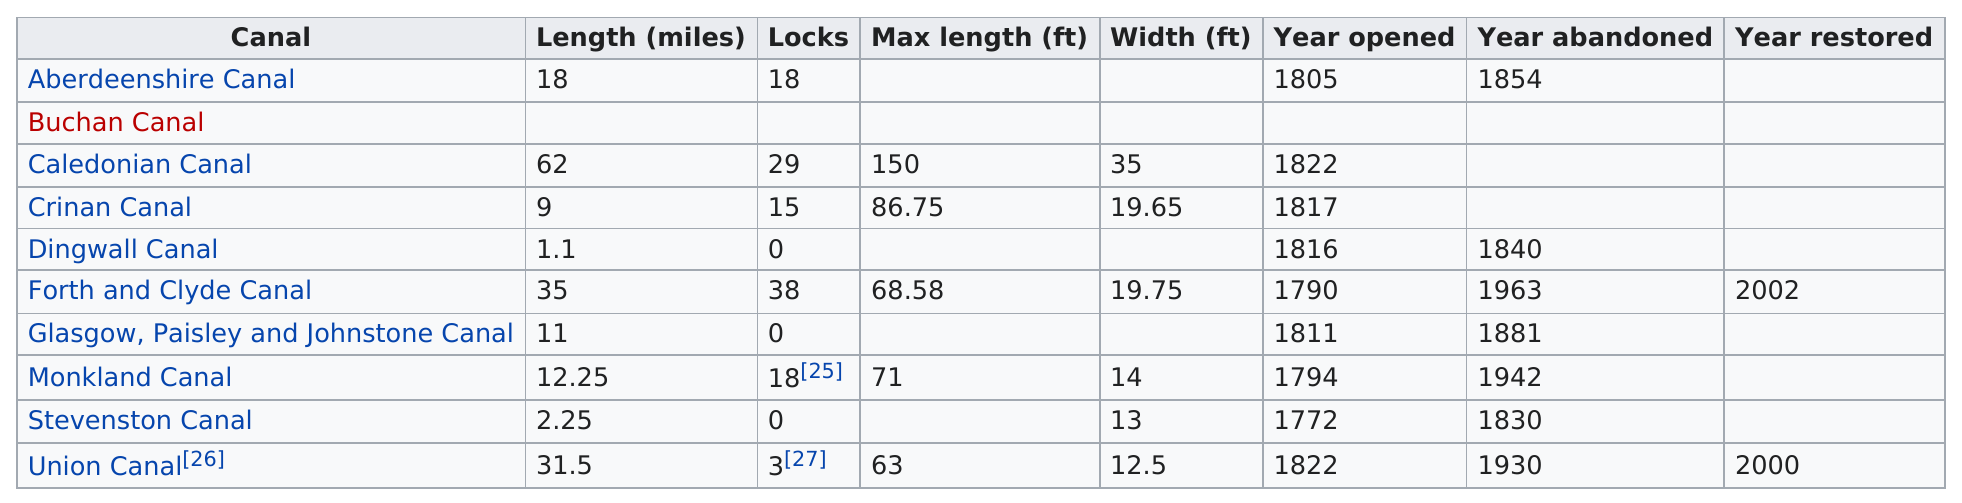Draw attention to some important aspects in this diagram. There are three canals that are longer than thirty miles. There are 10 canals in Scotland. The Dingwall Canal was 1.1 miles long. The Stevenston Canal was the first canal opened in Scotland. There are three canals that are longer than the Monkland Canal. 